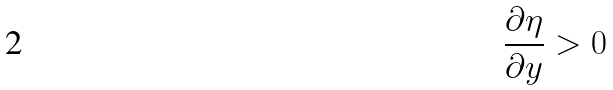Convert formula to latex. <formula><loc_0><loc_0><loc_500><loc_500>\frac { \partial \eta } { \partial y } > 0</formula> 